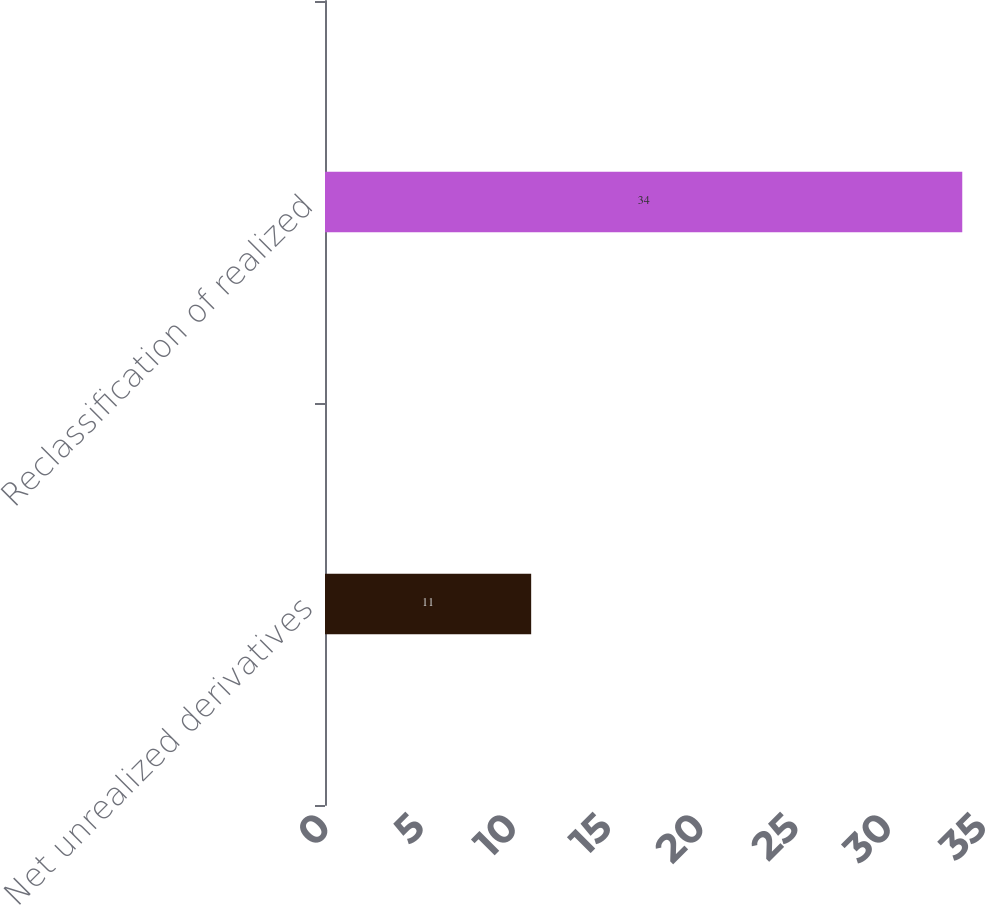Convert chart. <chart><loc_0><loc_0><loc_500><loc_500><bar_chart><fcel>Net unrealized derivatives<fcel>Reclassification of realized<nl><fcel>11<fcel>34<nl></chart> 